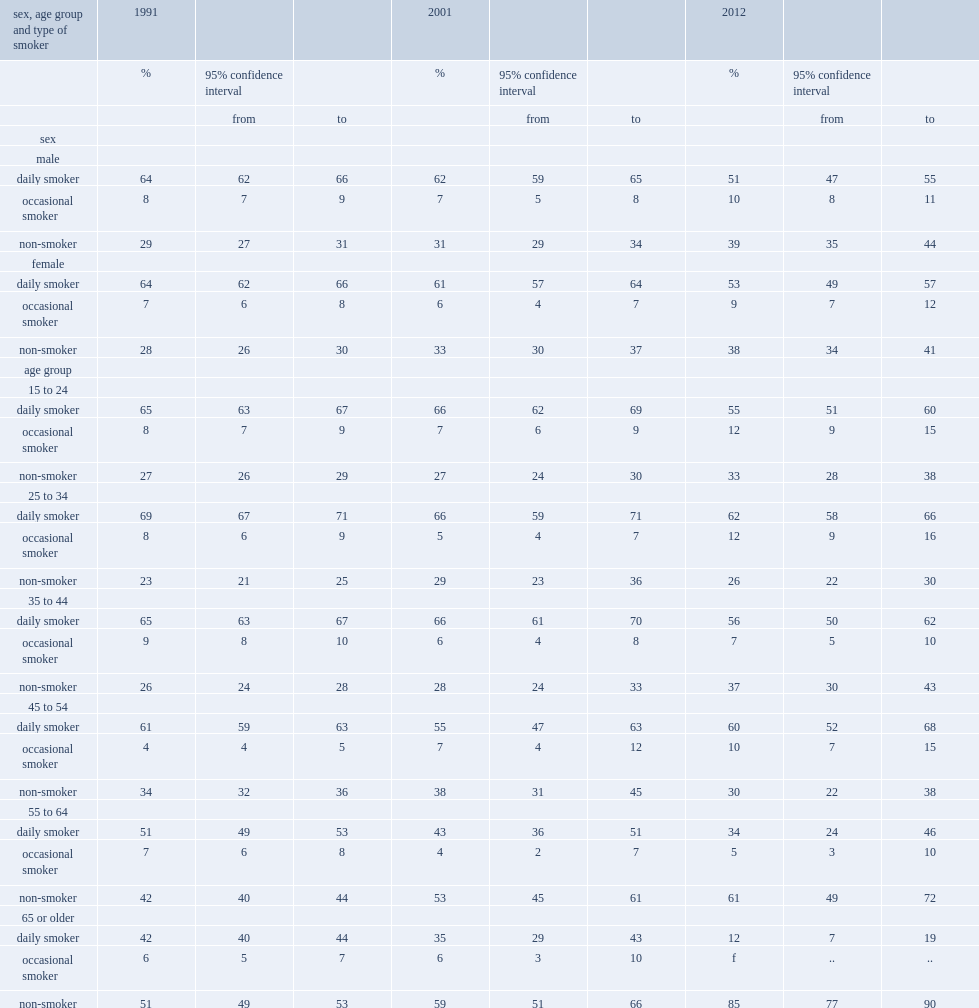What are the top 2 groups which had greatest decrease on daily smoking over the entire 1991-to-2012 period? 55 to 64 65 or older. Which age group has the lowest prevalence of smoking? 65 or older. Which age group had lowest prevalence on daily smoking in 2012? 65 or older. Which age group had second lowest prevalence on daily smoking in 2012? 55 to 64. Which age group were more likely to be daily smokers, 25-to-34-year-olds or 15-to-34-year-olds in 2012? 25 to 34. 